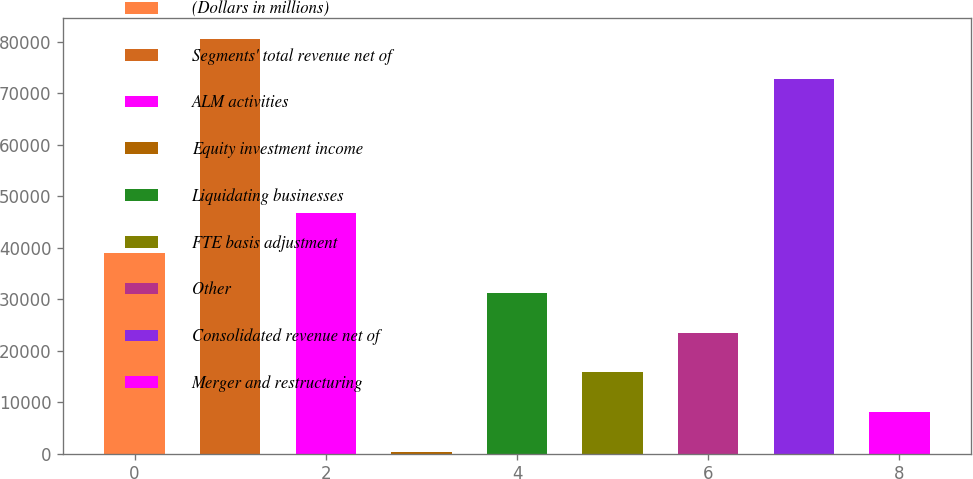Convert chart. <chart><loc_0><loc_0><loc_500><loc_500><bar_chart><fcel>(Dollars in millions)<fcel>Segments' total revenue net of<fcel>ALM activities<fcel>Equity investment income<fcel>Liquidating businesses<fcel>FTE basis adjustment<fcel>Other<fcel>Consolidated revenue net of<fcel>Merger and restructuring<nl><fcel>39024.5<fcel>80533.9<fcel>46776.4<fcel>265<fcel>31272.6<fcel>15768.8<fcel>23520.7<fcel>72782<fcel>8016.9<nl></chart> 